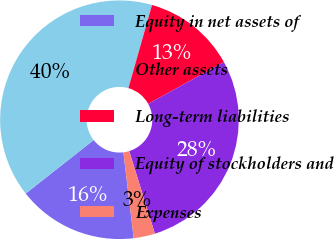Convert chart. <chart><loc_0><loc_0><loc_500><loc_500><pie_chart><fcel>Equity in net assets of<fcel>Other assets<fcel>Long-term liabilities<fcel>Equity of stockholders and<fcel>Expenses<nl><fcel>16.29%<fcel>40.02%<fcel>12.58%<fcel>28.22%<fcel>2.89%<nl></chart> 